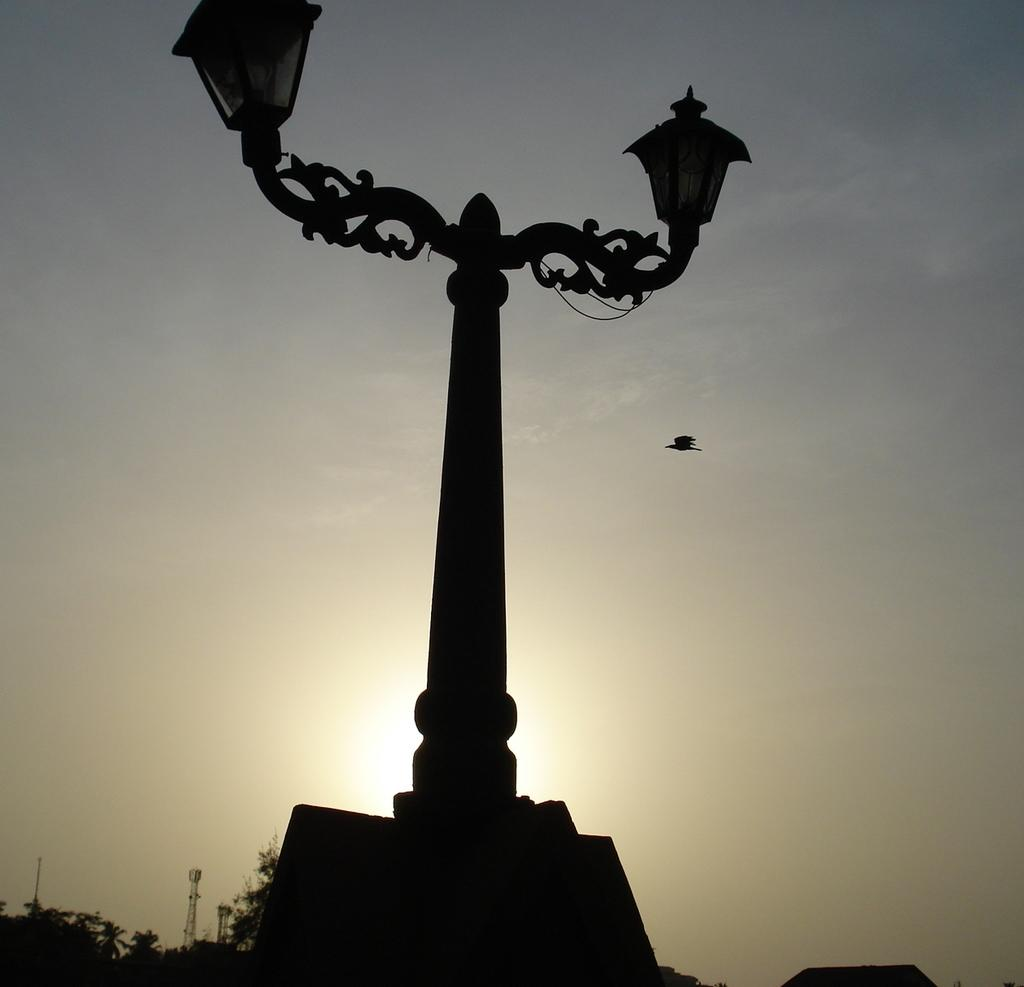What is attached to the pole in the image? There are lights attached to the pole in the image. What is happening in the background of the image? A bird is flying behind the pole. What can be seen in the sky in the image? The sky is visible in the image. What structures are located in the bottom left of the image? There are towers and trees in the bottom left of the image. How many spiders are crawling on the bird in the image? There are no spiders present in the image; only a bird flying behind the pole can be seen. What type of army is depicted in the image? There is no army depicted in the image; it features a pole with lights, a bird, and structures in the bottom left corner. 